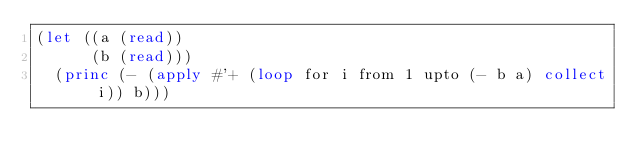Convert code to text. <code><loc_0><loc_0><loc_500><loc_500><_Lisp_>(let ((a (read))
      (b (read)))
  (princ (- (apply #'+ (loop for i from 1 upto (- b a) collect i)) b)))</code> 